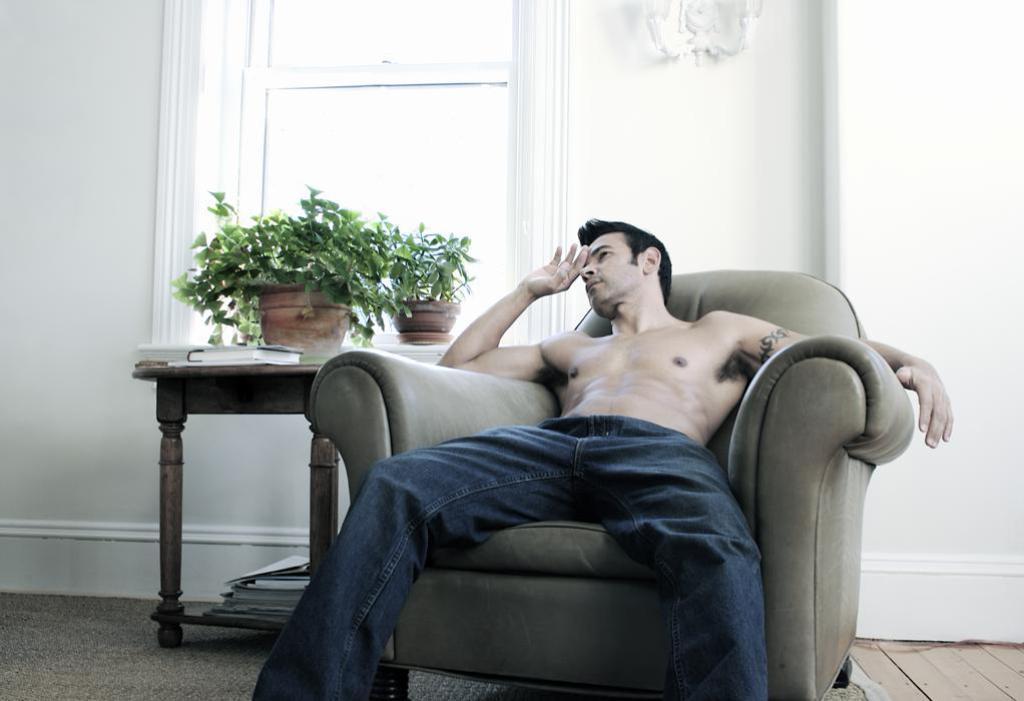Could you give a brief overview of what you see in this image? A shirtless guy is sitting on a chair sofa , to the left of him there is a small plant. In the background there is a window. 